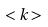Convert formula to latex. <formula><loc_0><loc_0><loc_500><loc_500>< k ></formula> 